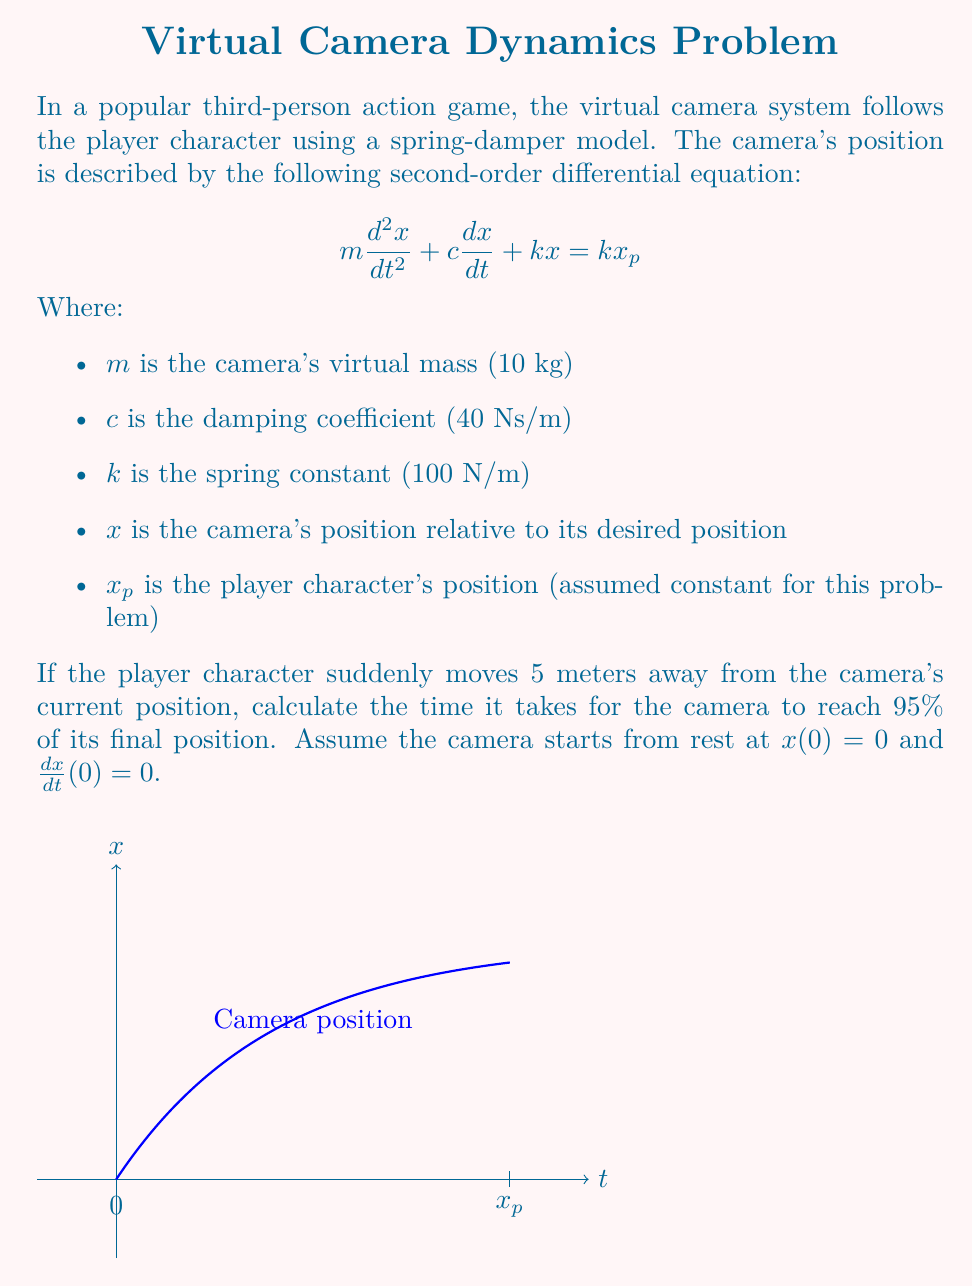Give your solution to this math problem. To solve this problem, we'll follow these steps:

1) First, we need to determine the natural frequency ($\omega_n$) and damping ratio ($\zeta$) of the system:

   $$\omega_n = \sqrt{\frac{k}{m}} = \sqrt{\frac{100}{10}} = \sqrt{10} \approx 3.16 \text{ rad/s}$$
   $$\zeta = \frac{c}{2\sqrt{km}} = \frac{40}{2\sqrt{100 \cdot 10}} = \frac{40}{20\sqrt{10}} = \frac{2}{\sqrt{10}} \approx 0.632$$

2) Since $0 < \zeta < 1$, this is an underdamped system. The general solution for an underdamped system is:

   $$x(t) = x_p(1 - e^{-\zeta\omega_n t}(\cos(\omega_d t) + \frac{\zeta}{\sqrt{1-\zeta^2}}\sin(\omega_d t)))$$

   where $\omega_d = \omega_n\sqrt{1-\zeta^2}$ is the damped natural frequency.

3) We want to find the time when $x(t) = 0.95x_p$. Substituting this into the equation:

   $$0.95 = 1 - e^{-\zeta\omega_n t}(\cos(\omega_d t) + \frac{\zeta}{\sqrt{1-\zeta^2}}\sin(\omega_d t))$$

4) Rearranging:

   $$0.05 = e^{-\zeta\omega_n t}(\cos(\omega_d t) + \frac{\zeta}{\sqrt{1-\zeta^2}}\sin(\omega_d t))$$

5) This equation cannot be solved analytically. We need to use numerical methods or plotting to find the solution. Using a numerical solver, we find:

   $$t \approx 1.497 \text{ seconds}$$

6) We can verify this result by plugging it back into the original equation.
Answer: 1.497 seconds 